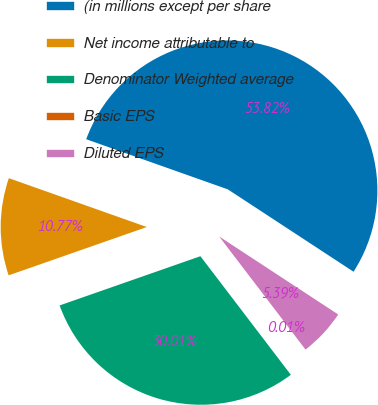<chart> <loc_0><loc_0><loc_500><loc_500><pie_chart><fcel>(in millions except per share<fcel>Net income attributable to<fcel>Denominator Weighted average<fcel>Basic EPS<fcel>Diluted EPS<nl><fcel>53.81%<fcel>10.77%<fcel>30.01%<fcel>0.01%<fcel>5.39%<nl></chart> 